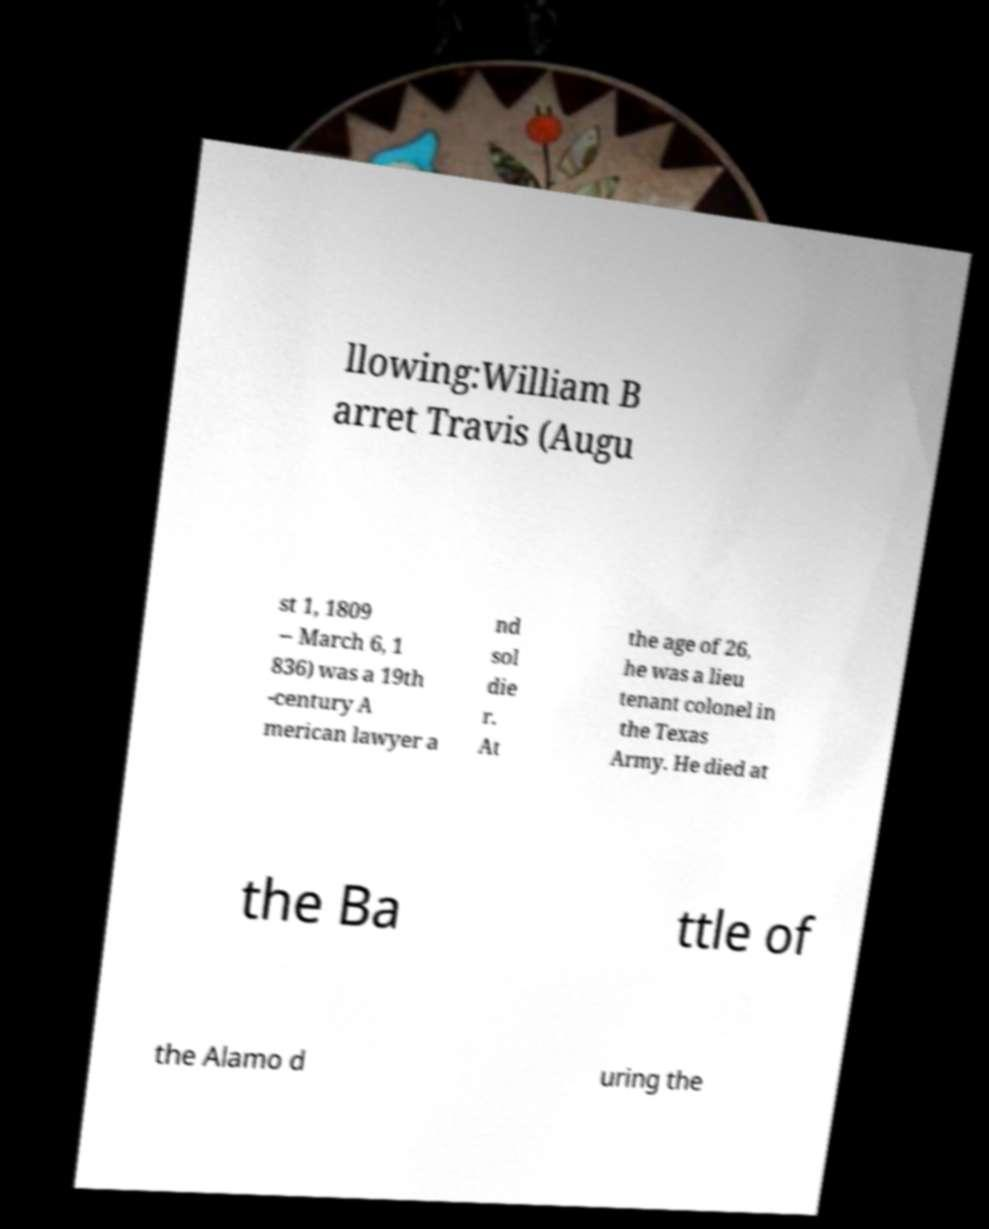I need the written content from this picture converted into text. Can you do that? llowing:William B arret Travis (Augu st 1, 1809 – March 6, 1 836) was a 19th -century A merican lawyer a nd sol die r. At the age of 26, he was a lieu tenant colonel in the Texas Army. He died at the Ba ttle of the Alamo d uring the 